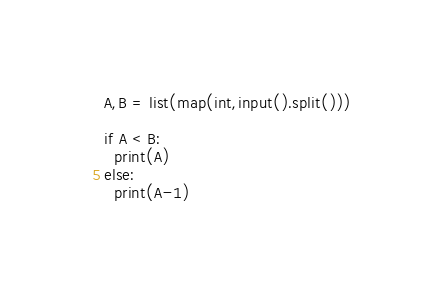<code> <loc_0><loc_0><loc_500><loc_500><_Python_>A,B = list(map(int,input().split()))

if A < B:
  print(A)
else:
  print(A-1)</code> 